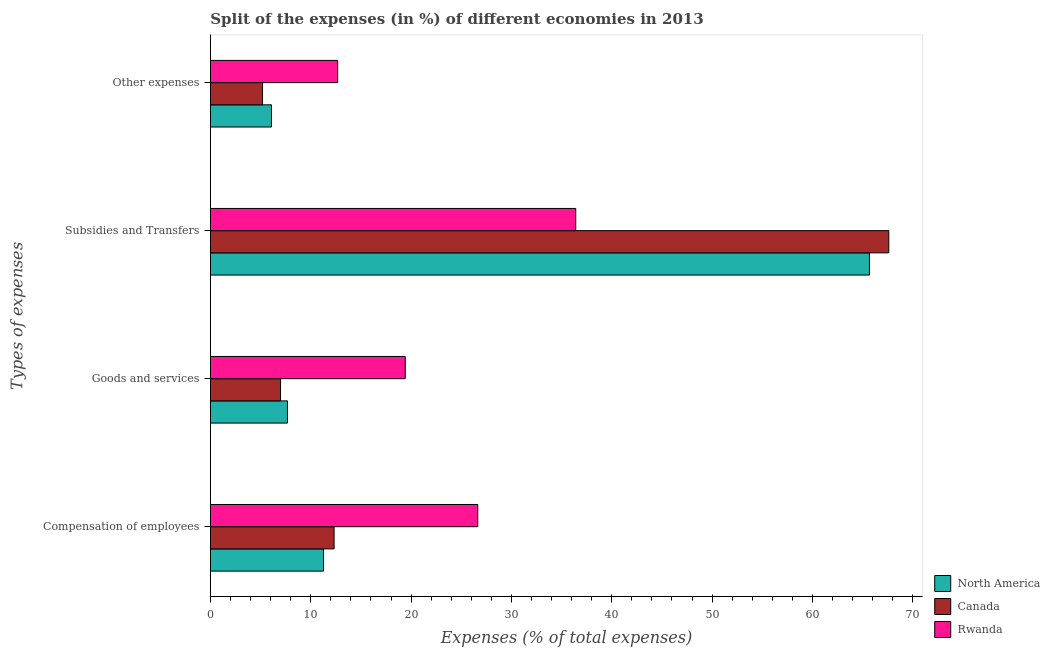What is the label of the 3rd group of bars from the top?
Your answer should be very brief. Goods and services. What is the percentage of amount spent on goods and services in Rwanda?
Make the answer very short. 19.42. Across all countries, what is the maximum percentage of amount spent on goods and services?
Provide a succinct answer. 19.42. Across all countries, what is the minimum percentage of amount spent on goods and services?
Your answer should be compact. 6.99. In which country was the percentage of amount spent on other expenses maximum?
Your response must be concise. Rwanda. In which country was the percentage of amount spent on goods and services minimum?
Your answer should be very brief. Canada. What is the total percentage of amount spent on compensation of employees in the graph?
Give a very brief answer. 50.25. What is the difference between the percentage of amount spent on goods and services in Canada and that in Rwanda?
Ensure brevity in your answer.  -12.43. What is the difference between the percentage of amount spent on compensation of employees in Rwanda and the percentage of amount spent on other expenses in North America?
Provide a short and direct response. 20.56. What is the average percentage of amount spent on goods and services per country?
Provide a succinct answer. 11.36. What is the difference between the percentage of amount spent on compensation of employees and percentage of amount spent on goods and services in North America?
Provide a short and direct response. 3.6. What is the ratio of the percentage of amount spent on other expenses in Rwanda to that in North America?
Ensure brevity in your answer.  2.08. Is the percentage of amount spent on subsidies in North America less than that in Rwanda?
Make the answer very short. No. What is the difference between the highest and the second highest percentage of amount spent on other expenses?
Your answer should be compact. 6.6. What is the difference between the highest and the lowest percentage of amount spent on subsidies?
Keep it short and to the point. 31.2. In how many countries, is the percentage of amount spent on compensation of employees greater than the average percentage of amount spent on compensation of employees taken over all countries?
Make the answer very short. 1. Is the sum of the percentage of amount spent on goods and services in Canada and Rwanda greater than the maximum percentage of amount spent on other expenses across all countries?
Provide a succinct answer. Yes. What does the 2nd bar from the top in Other expenses represents?
Offer a terse response. Canada. What does the 3rd bar from the bottom in Subsidies and Transfers represents?
Offer a very short reply. Rwanda. Is it the case that in every country, the sum of the percentage of amount spent on compensation of employees and percentage of amount spent on goods and services is greater than the percentage of amount spent on subsidies?
Your response must be concise. No. How many bars are there?
Make the answer very short. 12. What is the difference between two consecutive major ticks on the X-axis?
Your answer should be very brief. 10. Are the values on the major ticks of X-axis written in scientific E-notation?
Offer a terse response. No. Does the graph contain any zero values?
Give a very brief answer. No. How many legend labels are there?
Keep it short and to the point. 3. How are the legend labels stacked?
Give a very brief answer. Vertical. What is the title of the graph?
Your response must be concise. Split of the expenses (in %) of different economies in 2013. What is the label or title of the X-axis?
Your response must be concise. Expenses (% of total expenses). What is the label or title of the Y-axis?
Your answer should be compact. Types of expenses. What is the Expenses (% of total expenses) of North America in Compensation of employees?
Give a very brief answer. 11.28. What is the Expenses (% of total expenses) of Canada in Compensation of employees?
Make the answer very short. 12.33. What is the Expenses (% of total expenses) in Rwanda in Compensation of employees?
Give a very brief answer. 26.64. What is the Expenses (% of total expenses) of North America in Goods and services?
Offer a terse response. 7.68. What is the Expenses (% of total expenses) in Canada in Goods and services?
Keep it short and to the point. 6.99. What is the Expenses (% of total expenses) in Rwanda in Goods and services?
Your response must be concise. 19.42. What is the Expenses (% of total expenses) of North America in Subsidies and Transfers?
Make the answer very short. 65.68. What is the Expenses (% of total expenses) in Canada in Subsidies and Transfers?
Make the answer very short. 67.61. What is the Expenses (% of total expenses) in Rwanda in Subsidies and Transfers?
Give a very brief answer. 36.41. What is the Expenses (% of total expenses) in North America in Other expenses?
Your answer should be very brief. 6.09. What is the Expenses (% of total expenses) in Canada in Other expenses?
Your answer should be compact. 5.2. What is the Expenses (% of total expenses) in Rwanda in Other expenses?
Offer a terse response. 12.68. Across all Types of expenses, what is the maximum Expenses (% of total expenses) of North America?
Offer a very short reply. 65.68. Across all Types of expenses, what is the maximum Expenses (% of total expenses) in Canada?
Offer a terse response. 67.61. Across all Types of expenses, what is the maximum Expenses (% of total expenses) in Rwanda?
Your answer should be very brief. 36.41. Across all Types of expenses, what is the minimum Expenses (% of total expenses) of North America?
Keep it short and to the point. 6.09. Across all Types of expenses, what is the minimum Expenses (% of total expenses) of Canada?
Offer a terse response. 5.2. Across all Types of expenses, what is the minimum Expenses (% of total expenses) in Rwanda?
Offer a terse response. 12.68. What is the total Expenses (% of total expenses) of North America in the graph?
Offer a terse response. 90.72. What is the total Expenses (% of total expenses) in Canada in the graph?
Offer a very short reply. 92.12. What is the total Expenses (% of total expenses) of Rwanda in the graph?
Provide a succinct answer. 95.16. What is the difference between the Expenses (% of total expenses) of North America in Compensation of employees and that in Goods and services?
Keep it short and to the point. 3.6. What is the difference between the Expenses (% of total expenses) of Canada in Compensation of employees and that in Goods and services?
Give a very brief answer. 5.34. What is the difference between the Expenses (% of total expenses) of Rwanda in Compensation of employees and that in Goods and services?
Your answer should be compact. 7.23. What is the difference between the Expenses (% of total expenses) in North America in Compensation of employees and that in Subsidies and Transfers?
Give a very brief answer. -54.4. What is the difference between the Expenses (% of total expenses) of Canada in Compensation of employees and that in Subsidies and Transfers?
Provide a short and direct response. -55.28. What is the difference between the Expenses (% of total expenses) in Rwanda in Compensation of employees and that in Subsidies and Transfers?
Offer a very short reply. -9.76. What is the difference between the Expenses (% of total expenses) in North America in Compensation of employees and that in Other expenses?
Ensure brevity in your answer.  5.19. What is the difference between the Expenses (% of total expenses) in Canada in Compensation of employees and that in Other expenses?
Offer a very short reply. 7.13. What is the difference between the Expenses (% of total expenses) in Rwanda in Compensation of employees and that in Other expenses?
Make the answer very short. 13.96. What is the difference between the Expenses (% of total expenses) of North America in Goods and services and that in Subsidies and Transfers?
Make the answer very short. -58. What is the difference between the Expenses (% of total expenses) in Canada in Goods and services and that in Subsidies and Transfers?
Make the answer very short. -60.61. What is the difference between the Expenses (% of total expenses) in Rwanda in Goods and services and that in Subsidies and Transfers?
Your answer should be compact. -16.99. What is the difference between the Expenses (% of total expenses) in North America in Goods and services and that in Other expenses?
Make the answer very short. 1.59. What is the difference between the Expenses (% of total expenses) of Canada in Goods and services and that in Other expenses?
Give a very brief answer. 1.8. What is the difference between the Expenses (% of total expenses) in Rwanda in Goods and services and that in Other expenses?
Offer a very short reply. 6.74. What is the difference between the Expenses (% of total expenses) of North America in Subsidies and Transfers and that in Other expenses?
Your response must be concise. 59.59. What is the difference between the Expenses (% of total expenses) in Canada in Subsidies and Transfers and that in Other expenses?
Your answer should be compact. 62.41. What is the difference between the Expenses (% of total expenses) of Rwanda in Subsidies and Transfers and that in Other expenses?
Your answer should be very brief. 23.73. What is the difference between the Expenses (% of total expenses) in North America in Compensation of employees and the Expenses (% of total expenses) in Canada in Goods and services?
Make the answer very short. 4.29. What is the difference between the Expenses (% of total expenses) of North America in Compensation of employees and the Expenses (% of total expenses) of Rwanda in Goods and services?
Your response must be concise. -8.14. What is the difference between the Expenses (% of total expenses) of Canada in Compensation of employees and the Expenses (% of total expenses) of Rwanda in Goods and services?
Provide a succinct answer. -7.09. What is the difference between the Expenses (% of total expenses) of North America in Compensation of employees and the Expenses (% of total expenses) of Canada in Subsidies and Transfers?
Offer a terse response. -56.33. What is the difference between the Expenses (% of total expenses) of North America in Compensation of employees and the Expenses (% of total expenses) of Rwanda in Subsidies and Transfers?
Ensure brevity in your answer.  -25.13. What is the difference between the Expenses (% of total expenses) of Canada in Compensation of employees and the Expenses (% of total expenses) of Rwanda in Subsidies and Transfers?
Provide a short and direct response. -24.08. What is the difference between the Expenses (% of total expenses) of North America in Compensation of employees and the Expenses (% of total expenses) of Canada in Other expenses?
Give a very brief answer. 6.08. What is the difference between the Expenses (% of total expenses) of North America in Compensation of employees and the Expenses (% of total expenses) of Rwanda in Other expenses?
Provide a succinct answer. -1.41. What is the difference between the Expenses (% of total expenses) of Canada in Compensation of employees and the Expenses (% of total expenses) of Rwanda in Other expenses?
Your answer should be compact. -0.36. What is the difference between the Expenses (% of total expenses) of North America in Goods and services and the Expenses (% of total expenses) of Canada in Subsidies and Transfers?
Your answer should be compact. -59.92. What is the difference between the Expenses (% of total expenses) of North America in Goods and services and the Expenses (% of total expenses) of Rwanda in Subsidies and Transfers?
Your answer should be very brief. -28.73. What is the difference between the Expenses (% of total expenses) in Canada in Goods and services and the Expenses (% of total expenses) in Rwanda in Subsidies and Transfers?
Make the answer very short. -29.42. What is the difference between the Expenses (% of total expenses) in North America in Goods and services and the Expenses (% of total expenses) in Canada in Other expenses?
Your response must be concise. 2.48. What is the difference between the Expenses (% of total expenses) in North America in Goods and services and the Expenses (% of total expenses) in Rwanda in Other expenses?
Provide a succinct answer. -5. What is the difference between the Expenses (% of total expenses) in Canada in Goods and services and the Expenses (% of total expenses) in Rwanda in Other expenses?
Provide a succinct answer. -5.69. What is the difference between the Expenses (% of total expenses) in North America in Subsidies and Transfers and the Expenses (% of total expenses) in Canada in Other expenses?
Offer a terse response. 60.48. What is the difference between the Expenses (% of total expenses) of North America in Subsidies and Transfers and the Expenses (% of total expenses) of Rwanda in Other expenses?
Ensure brevity in your answer.  53. What is the difference between the Expenses (% of total expenses) in Canada in Subsidies and Transfers and the Expenses (% of total expenses) in Rwanda in Other expenses?
Provide a succinct answer. 54.92. What is the average Expenses (% of total expenses) of North America per Types of expenses?
Offer a terse response. 22.68. What is the average Expenses (% of total expenses) of Canada per Types of expenses?
Provide a succinct answer. 23.03. What is the average Expenses (% of total expenses) in Rwanda per Types of expenses?
Ensure brevity in your answer.  23.79. What is the difference between the Expenses (% of total expenses) in North America and Expenses (% of total expenses) in Canada in Compensation of employees?
Keep it short and to the point. -1.05. What is the difference between the Expenses (% of total expenses) in North America and Expenses (% of total expenses) in Rwanda in Compensation of employees?
Keep it short and to the point. -15.37. What is the difference between the Expenses (% of total expenses) in Canada and Expenses (% of total expenses) in Rwanda in Compensation of employees?
Your response must be concise. -14.32. What is the difference between the Expenses (% of total expenses) in North America and Expenses (% of total expenses) in Canada in Goods and services?
Your response must be concise. 0.69. What is the difference between the Expenses (% of total expenses) in North America and Expenses (% of total expenses) in Rwanda in Goods and services?
Ensure brevity in your answer.  -11.74. What is the difference between the Expenses (% of total expenses) of Canada and Expenses (% of total expenses) of Rwanda in Goods and services?
Give a very brief answer. -12.43. What is the difference between the Expenses (% of total expenses) of North America and Expenses (% of total expenses) of Canada in Subsidies and Transfers?
Provide a short and direct response. -1.93. What is the difference between the Expenses (% of total expenses) in North America and Expenses (% of total expenses) in Rwanda in Subsidies and Transfers?
Offer a very short reply. 29.27. What is the difference between the Expenses (% of total expenses) of Canada and Expenses (% of total expenses) of Rwanda in Subsidies and Transfers?
Offer a very short reply. 31.2. What is the difference between the Expenses (% of total expenses) of North America and Expenses (% of total expenses) of Canada in Other expenses?
Your answer should be compact. 0.89. What is the difference between the Expenses (% of total expenses) of North America and Expenses (% of total expenses) of Rwanda in Other expenses?
Provide a short and direct response. -6.6. What is the difference between the Expenses (% of total expenses) in Canada and Expenses (% of total expenses) in Rwanda in Other expenses?
Your response must be concise. -7.49. What is the ratio of the Expenses (% of total expenses) in North America in Compensation of employees to that in Goods and services?
Offer a very short reply. 1.47. What is the ratio of the Expenses (% of total expenses) of Canada in Compensation of employees to that in Goods and services?
Keep it short and to the point. 1.76. What is the ratio of the Expenses (% of total expenses) of Rwanda in Compensation of employees to that in Goods and services?
Provide a short and direct response. 1.37. What is the ratio of the Expenses (% of total expenses) of North America in Compensation of employees to that in Subsidies and Transfers?
Keep it short and to the point. 0.17. What is the ratio of the Expenses (% of total expenses) of Canada in Compensation of employees to that in Subsidies and Transfers?
Provide a succinct answer. 0.18. What is the ratio of the Expenses (% of total expenses) in Rwanda in Compensation of employees to that in Subsidies and Transfers?
Give a very brief answer. 0.73. What is the ratio of the Expenses (% of total expenses) of North America in Compensation of employees to that in Other expenses?
Offer a terse response. 1.85. What is the ratio of the Expenses (% of total expenses) of Canada in Compensation of employees to that in Other expenses?
Your answer should be very brief. 2.37. What is the ratio of the Expenses (% of total expenses) of Rwanda in Compensation of employees to that in Other expenses?
Give a very brief answer. 2.1. What is the ratio of the Expenses (% of total expenses) of North America in Goods and services to that in Subsidies and Transfers?
Your response must be concise. 0.12. What is the ratio of the Expenses (% of total expenses) of Canada in Goods and services to that in Subsidies and Transfers?
Give a very brief answer. 0.1. What is the ratio of the Expenses (% of total expenses) of Rwanda in Goods and services to that in Subsidies and Transfers?
Provide a succinct answer. 0.53. What is the ratio of the Expenses (% of total expenses) in North America in Goods and services to that in Other expenses?
Give a very brief answer. 1.26. What is the ratio of the Expenses (% of total expenses) in Canada in Goods and services to that in Other expenses?
Offer a very short reply. 1.35. What is the ratio of the Expenses (% of total expenses) in Rwanda in Goods and services to that in Other expenses?
Provide a succinct answer. 1.53. What is the ratio of the Expenses (% of total expenses) of North America in Subsidies and Transfers to that in Other expenses?
Offer a very short reply. 10.79. What is the ratio of the Expenses (% of total expenses) in Canada in Subsidies and Transfers to that in Other expenses?
Ensure brevity in your answer.  13.01. What is the ratio of the Expenses (% of total expenses) in Rwanda in Subsidies and Transfers to that in Other expenses?
Your answer should be very brief. 2.87. What is the difference between the highest and the second highest Expenses (% of total expenses) in North America?
Offer a terse response. 54.4. What is the difference between the highest and the second highest Expenses (% of total expenses) in Canada?
Provide a succinct answer. 55.28. What is the difference between the highest and the second highest Expenses (% of total expenses) of Rwanda?
Your answer should be compact. 9.76. What is the difference between the highest and the lowest Expenses (% of total expenses) in North America?
Provide a short and direct response. 59.59. What is the difference between the highest and the lowest Expenses (% of total expenses) of Canada?
Give a very brief answer. 62.41. What is the difference between the highest and the lowest Expenses (% of total expenses) of Rwanda?
Provide a short and direct response. 23.73. 